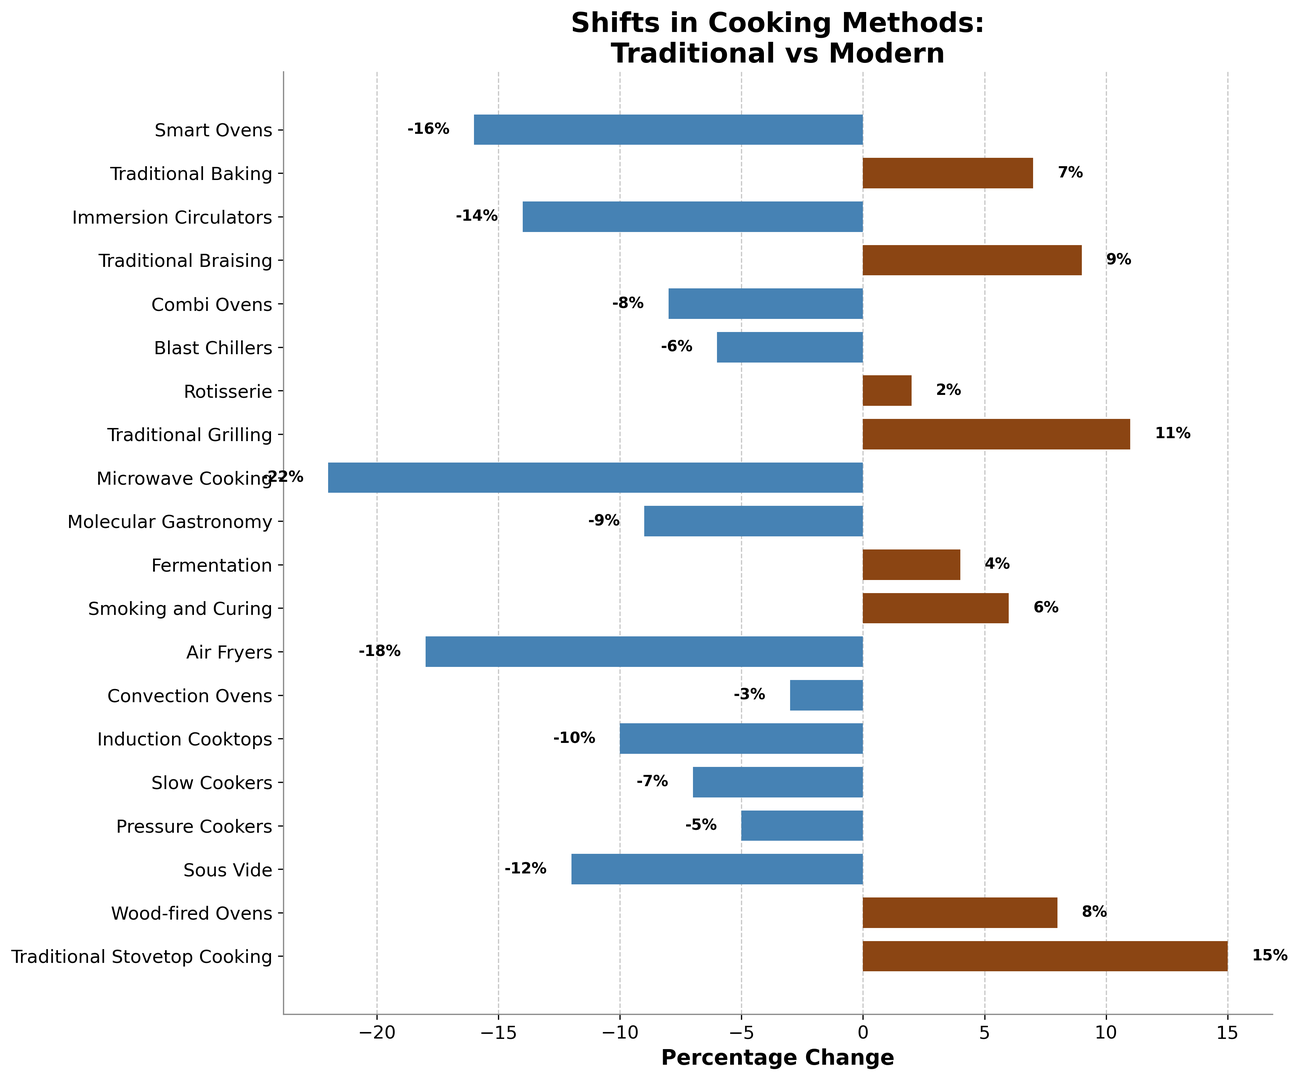Which cooking method has the highest positive percentage change? To find the method with the highest positive percentage change, look for the bar extending the most to the right. Traditional Stovetop Cooking shows the highest positive change of 15%.
Answer: Traditional Stovetop Cooking Which cooking method has the largest negative percentage change? To find the method with the largest negative percentage change, look for the bar extending the most to the left. Microwave Cooking shows the largest negative change of -22%.
Answer: Microwave Cooking What is the combined percentage change of all traditional methods (Stovetop Cooking, Grilling, Braising, and Baking)? Sum the percentage changes for Traditional Stovetop Cooking (15), Traditional Grilling (11), Traditional Braising (9), and Traditional Baking (7). The total is 15 + 11 + 9 + 7 = 42%.
Answer: 42% How does the percentage change of Air Fryers compare to Induction Cooktops? To compare, note the values for Air Fryers (-18%) and Induction Cooktops (-10%). Air Fryers have a more significant negative change than Induction Cooktops.
Answer: Air Fryers have a more significant negative change Which method, Smoking and Curing or Molecular Gastronomy, has a higher percentage change? Compare Smoking and Curing (6%) with Molecular Gastronomy (-9%). Smoking and Curing has a higher positive percentage change.
Answer: Smoking and Curing Among Sous Vide, Pressure Cookers, and Slow Cookers, which has the smallest percentage decrease? Compare the negative values for Sous Vide (-12%), Pressure Cookers (-5%), and Slow Cookers (-7%), where Pressure Cookers has the smallest decrease.
Answer: Pressure Cookers What is the difference in percentage change between Smart Ovens and Traditional Grilling? Subtract the percentage change of Smart Ovens (-16%) from Traditional Grilling (11%). 11 - (-16) = 27%.
Answer: 27% What is the average percentage change of all modern appliances listed? To find the average, sum the percentage changes of Sous Vide (-12), Pressure Cookers (-5), Slow Cookers (-7), Induction Cooktops (-10), Convection Ovens (-3), Air Fryers (-18), Molecular Gastronomy (-9), Microwave Cooking (-22), Blast Chillers (-6), Combi Ovens (-8), and Smart Ovens (-16). Total sum: -105. The number of data points: 11. Average = -105 / 11 ≈ -9.55%.
Answer: -9.55% Do more traditional methods show positive changes compared to modern appliances? Count the number of traditional methods with positive changes (Traditional Stovetop Cooking, Wood-fired Ovens, Traditional Grilling, Rotisserie, Traditional Braising, Traditional Baking) and compare with the number of modern appliances with positive changes (Smoking and Curing, Fermentation). Traditional methods have more positive changes (6 vs 2).
Answer: Yes What is the range of percentage changes for the methods shown? Identify the maximum positive change (15% for Traditional Stovetop Cooking) and the minimum negative change (-22% for Microwave Cooking). The range is 15 - (-22) = 37%.
Answer: 37% 